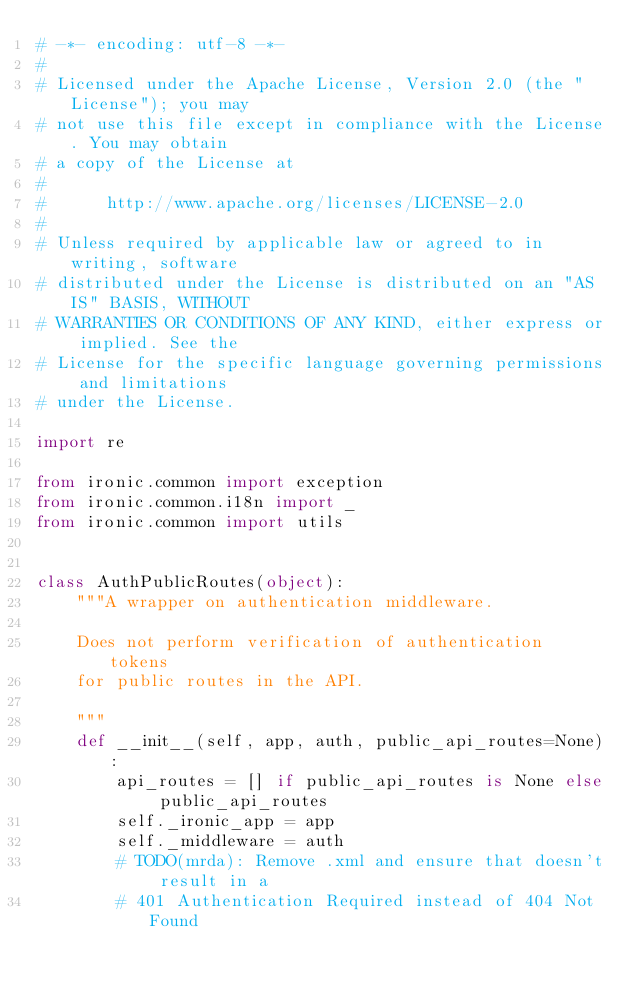Convert code to text. <code><loc_0><loc_0><loc_500><loc_500><_Python_># -*- encoding: utf-8 -*-
#
# Licensed under the Apache License, Version 2.0 (the "License"); you may
# not use this file except in compliance with the License. You may obtain
# a copy of the License at
#
#      http://www.apache.org/licenses/LICENSE-2.0
#
# Unless required by applicable law or agreed to in writing, software
# distributed under the License is distributed on an "AS IS" BASIS, WITHOUT
# WARRANTIES OR CONDITIONS OF ANY KIND, either express or implied. See the
# License for the specific language governing permissions and limitations
# under the License.

import re

from ironic.common import exception
from ironic.common.i18n import _
from ironic.common import utils


class AuthPublicRoutes(object):
    """A wrapper on authentication middleware.

    Does not perform verification of authentication tokens
    for public routes in the API.

    """
    def __init__(self, app, auth, public_api_routes=None):
        api_routes = [] if public_api_routes is None else public_api_routes
        self._ironic_app = app
        self._middleware = auth
        # TODO(mrda): Remove .xml and ensure that doesn't result in a
        # 401 Authentication Required instead of 404 Not Found</code> 